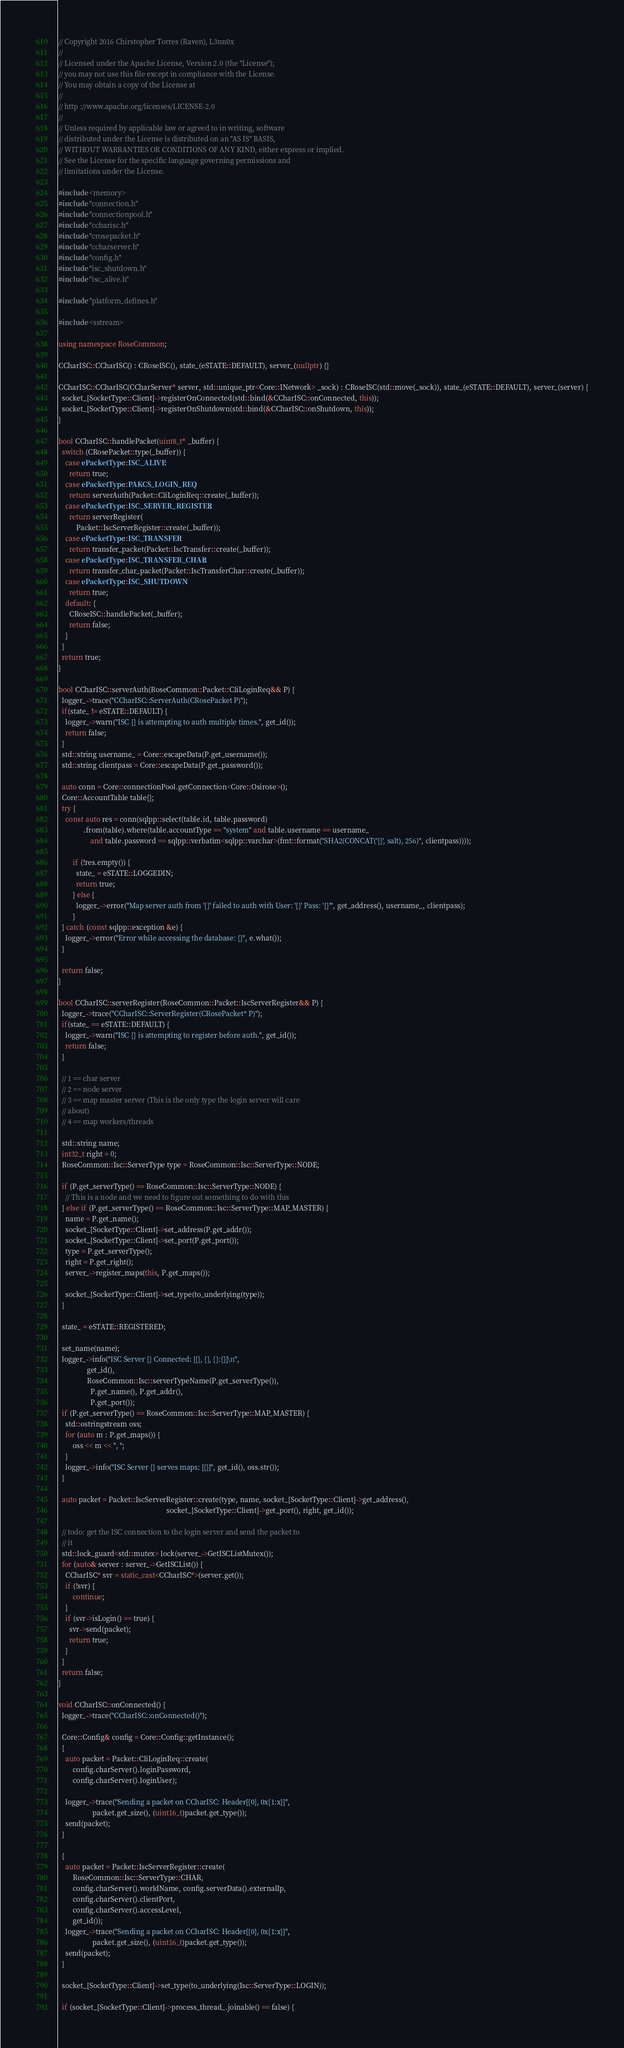<code> <loc_0><loc_0><loc_500><loc_500><_C++_>// Copyright 2016 Chirstopher Torres (Raven), L3nn0x
//
// Licensed under the Apache License, Version 2.0 (the "License");
// you may not use this file except in compliance with the License.
// You may obtain a copy of the License at
//
// http ://www.apache.org/licenses/LICENSE-2.0
//
// Unless required by applicable law or agreed to in writing, software
// distributed under the License is distributed on an "AS IS" BASIS,
// WITHOUT WARRANTIES OR CONDITIONS OF ANY KIND, either express or implied.
// See the License for the specific language governing permissions and
// limitations under the License.

#include <memory>
#include "connection.h"
#include "connectionpool.h"
#include "ccharisc.h"
#include "crosepacket.h"
#include "ccharserver.h"
#include "config.h"
#include "isc_shutdown.h"
#include "isc_alive.h"

#include "platform_defines.h"

#include <sstream>

using namespace RoseCommon;

CCharISC::CCharISC() : CRoseISC(), state_(eSTATE::DEFAULT), server_(nullptr) {}

CCharISC::CCharISC(CCharServer* server, std::unique_ptr<Core::INetwork> _sock) : CRoseISC(std::move(_sock)), state_(eSTATE::DEFAULT), server_(server) {
  socket_[SocketType::Client]->registerOnConnected(std::bind(&CCharISC::onConnected, this));
  socket_[SocketType::Client]->registerOnShutdown(std::bind(&CCharISC::onShutdown, this));
}

bool CCharISC::handlePacket(uint8_t* _buffer) {
  switch (CRosePacket::type(_buffer)) {
    case ePacketType::ISC_ALIVE:
      return true;
    case ePacketType::PAKCS_LOGIN_REQ:
      return serverAuth(Packet::CliLoginReq::create(_buffer));
    case ePacketType::ISC_SERVER_REGISTER:
      return serverRegister(
          Packet::IscServerRegister::create(_buffer));
    case ePacketType::ISC_TRANSFER:
      return transfer_packet(Packet::IscTransfer::create(_buffer));
    case ePacketType::ISC_TRANSFER_CHAR:
      return transfer_char_packet(Packet::IscTransferChar::create(_buffer));
    case ePacketType::ISC_SHUTDOWN:
      return true;
    default: {
      CRoseISC::handlePacket(_buffer);
      return false;
    }
  }
  return true;
}

bool CCharISC::serverAuth(RoseCommon::Packet::CliLoginReq&& P) {
  logger_->trace("CCharISC::ServerAuth(CRosePacket P)");
  if(state_ != eSTATE::DEFAULT) {
    logger_->warn("ISC {} is attempting to auth multiple times.", get_id());
    return false;
  }
  std::string username_ = Core::escapeData(P.get_username());
  std::string clientpass = Core::escapeData(P.get_password());

  auto conn = Core::connectionPool.getConnection<Core::Osirose>();
  Core::AccountTable table{};
  try {
    const auto res = conn(sqlpp::select(table.id, table.password)
              .from(table).where(table.accountType == "system" and table.username == username_
                  and table.password == sqlpp::verbatim<sqlpp::varchar>(fmt::format("SHA2(CONCAT('{}', salt), 256)", clientpass))));

        if (!res.empty()) {
          state_ = eSTATE::LOGGEDIN;
          return true;
        } else {
          logger_->error("Map server auth from '{}' failed to auth with User: '{}' Pass: '{}'", get_address(), username_, clientpass);
        }
  } catch (const sqlpp::exception &e) {
    logger_->error("Error while accessing the database: {}", e.what());
  }

  return false;
}

bool CCharISC::serverRegister(RoseCommon::Packet::IscServerRegister&& P) {
  logger_->trace("CCharISC::ServerRegister(CRosePacket* P)");
  if(state_ == eSTATE::DEFAULT) {
    logger_->warn("ISC {} is attempting to register before auth.", get_id());
    return false;
  }

  // 1 == char server
  // 2 == node server
  // 3 == map master server (This is the only type the login server will care
  // about)
  // 4 == map workers/threads

  std::string name;
  int32_t right = 0;
  RoseCommon::Isc::ServerType type = RoseCommon::Isc::ServerType::NODE;

  if (P.get_serverType() == RoseCommon::Isc::ServerType::NODE) {
    // This is a node and we need to figure out something to do with this
  } else if (P.get_serverType() == RoseCommon::Isc::ServerType::MAP_MASTER) {
    name = P.get_name();
    socket_[SocketType::Client]->set_address(P.get_addr());
    socket_[SocketType::Client]->set_port(P.get_port());
    type = P.get_serverType();
    right = P.get_right();
    server_->register_maps(this, P.get_maps());

    socket_[SocketType::Client]->set_type(to_underlying(type));
  }

  state_ = eSTATE::REGISTERED;

  set_name(name);
  logger_->info("ISC Server {} Connected: [{}, {}, {}:{}]\n",
                get_id(),
                RoseCommon::Isc::serverTypeName(P.get_serverType()),
                  P.get_name(), P.get_addr(),
                  P.get_port());
  if (P.get_serverType() == RoseCommon::Isc::ServerType::MAP_MASTER) {
    std::ostringstream oss;
    for (auto m : P.get_maps()) {
        oss << m << ", ";
    }
    logger_->info("ISC Server {} serves maps: [{}]", get_id(), oss.str());
  }

  auto packet = Packet::IscServerRegister::create(type, name, socket_[SocketType::Client]->get_address(),
                                                             socket_[SocketType::Client]->get_port(), right, get_id());

  // todo: get the ISC connection to the login server and send the packet to
  // it
  std::lock_guard<std::mutex> lock(server_->GetISCListMutex());
  for (auto& server : server_->GetISCList()) {
    CCharISC* svr = static_cast<CCharISC*>(server.get());
    if (!svr) {
        continue;
    }
    if (svr->isLogin() == true) {
      svr->send(packet);
      return true;
    }
  }
  return false;
}

void CCharISC::onConnected() {
  logger_->trace("CCharISC::onConnected()");

  Core::Config& config = Core::Config::getInstance();
  {
    auto packet = Packet::CliLoginReq::create(
        config.charServer().loginPassword,
        config.charServer().loginUser);

    logger_->trace("Sending a packet on CCharISC: Header[{0}, 0x{1:x}]",
                   packet.get_size(), (uint16_t)packet.get_type());
    send(packet);
  }

  {
    auto packet = Packet::IscServerRegister::create(
        RoseCommon::Isc::ServerType::CHAR,
        config.charServer().worldName, config.serverData().externalIp,
        config.charServer().clientPort,
        config.charServer().accessLevel,
        get_id());
    logger_->trace("Sending a packet on CCharISC: Header[{0}, 0x{1:x}]",
                   packet.get_size(), (uint16_t)packet.get_type());
    send(packet);
  }

  socket_[SocketType::Client]->set_type(to_underlying(Isc::ServerType::LOGIN));

  if (socket_[SocketType::Client]->process_thread_.joinable() == false) {</code> 